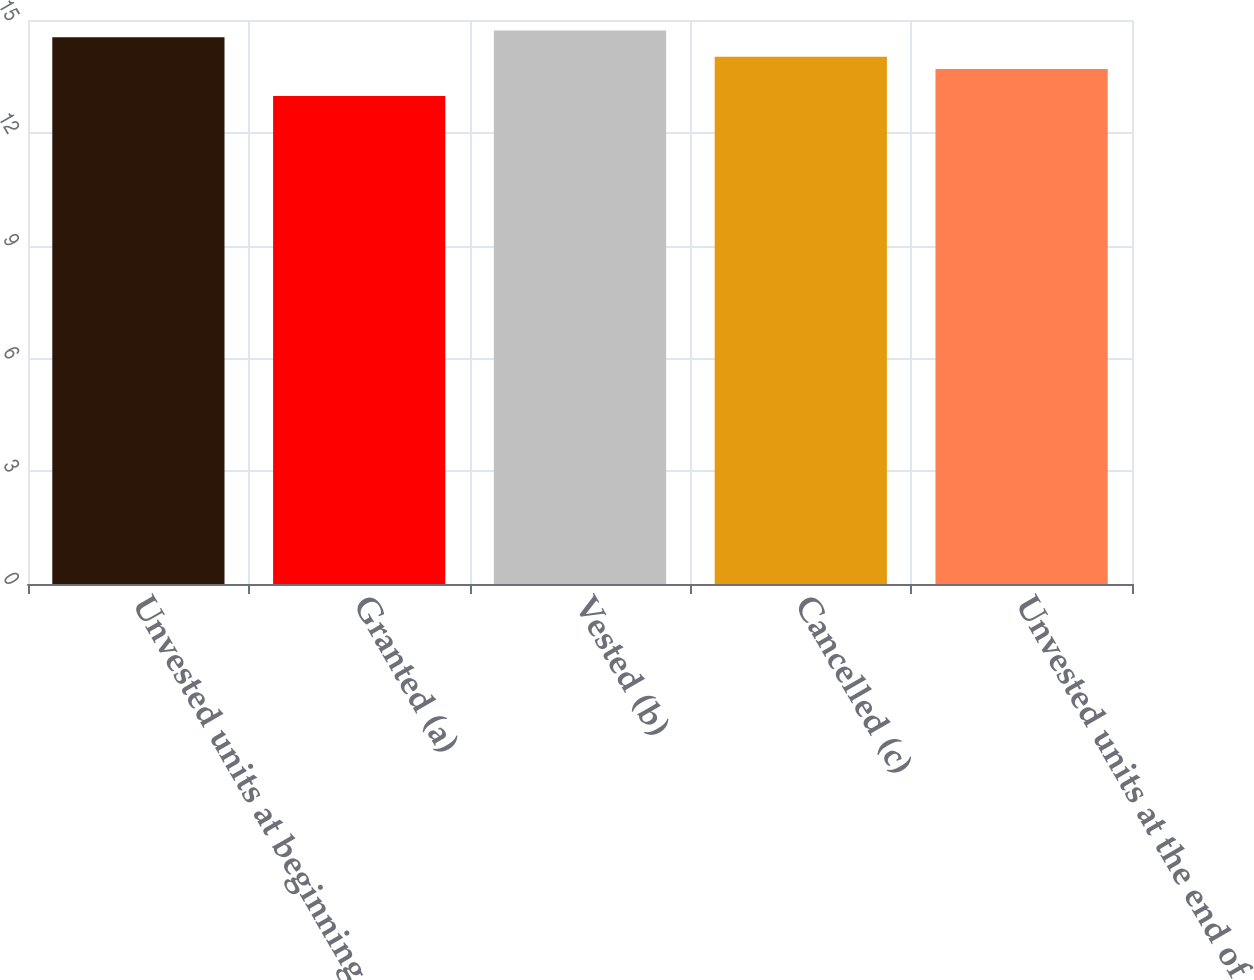Convert chart. <chart><loc_0><loc_0><loc_500><loc_500><bar_chart><fcel>Unvested units at beginning of<fcel>Granted (a)<fcel>Vested (b)<fcel>Cancelled (c)<fcel>Unvested units at the end of<nl><fcel>14.54<fcel>12.98<fcel>14.72<fcel>14.02<fcel>13.7<nl></chart> 